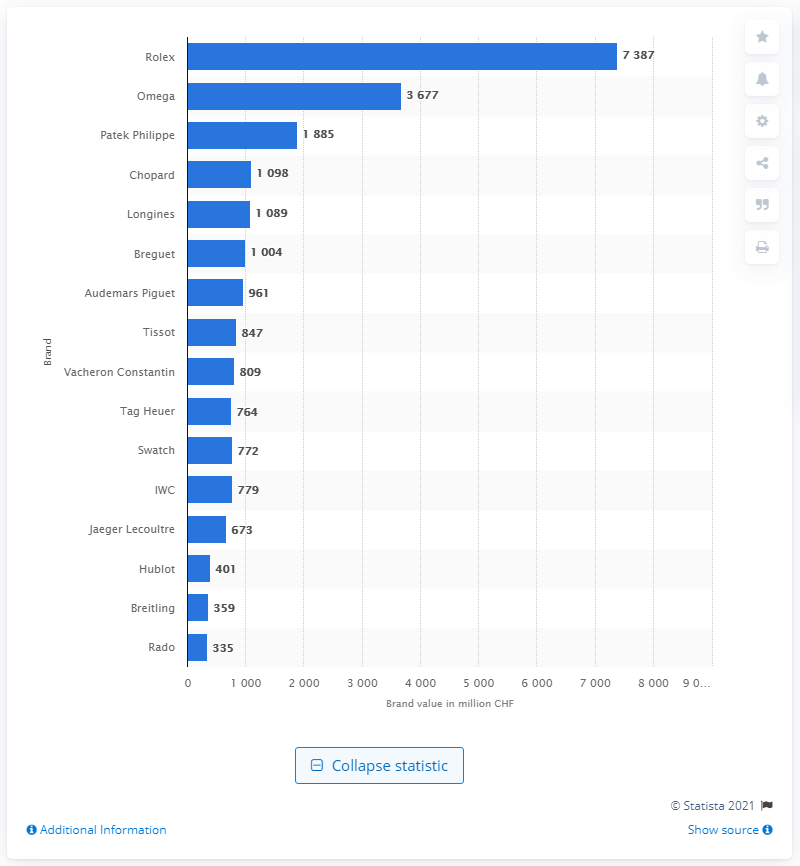Outline some significant characteristics in this image. One of the most powerful brands in the world, according to many, is Rolex. 